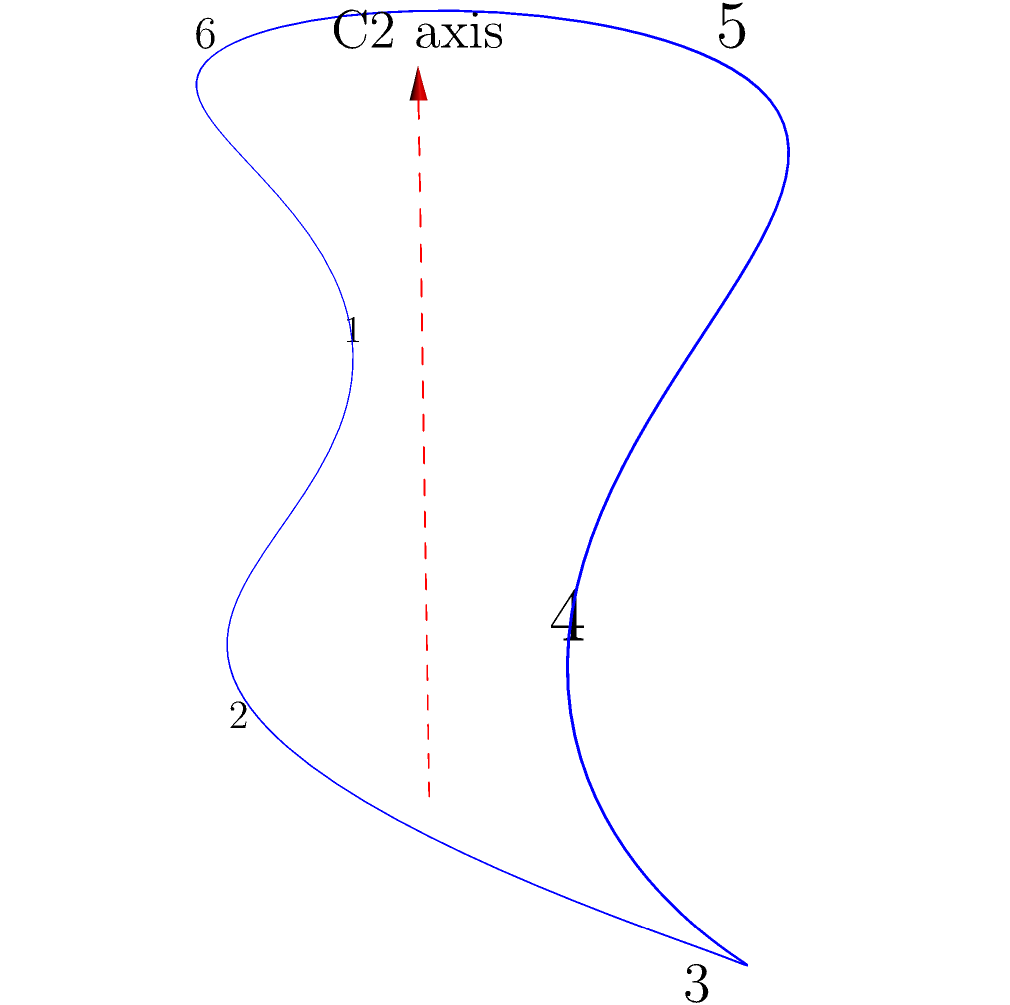Consider the cyclohexane chair conformation shown above, which is relevant to drug stereochemistry. Identify the order of the rotational symmetry operation about the C2 axis (shown in red) and determine how many different positions are generated by applying this operation repeatedly. How does this symmetry relate to the potential chirality of substituted cyclohexanes? To answer this question, let's follow these steps:

1. Understand the C2 axis:
   The C2 axis is a two-fold rotation axis that passes through the center of the cyclohexane ring.

2. Determine the order of rotation:
   - A C2 axis involves a 180° rotation (360°/2 = 180°).
   - This means the order of rotation is 2, as two rotations bring the molecule back to its original position.

3. Count the number of unique positions:
   - Starting position: original conformation
   - After one 180° rotation: new position
   - After two 180° rotations: back to the original position
   Thus, there are 2 unique positions generated by this symmetry operation.

4. Relate to chirality:
   - The C2 axis creates a plane of symmetry in the cyclohexane molecule.
   - This symmetry element means that unsubstituted cyclohexane is achiral.
   - However, if we substitute different groups on carbons not related by the C2 axis (e.g., carbons 1 and 4), we can create a chiral molecule.
   - Substitutions on carbons related by the C2 axis (e.g., carbons 2 and 5) will maintain the symmetry and result in an achiral molecule.

5. Pharmaceutical relevance:
   - Understanding these symmetry operations is crucial in drug design, as the chirality of a molecule can significantly affect its biological activity and interactions with target receptors.
   - This knowledge helps in predicting and controlling the stereochemistry of drug molecules, which is essential for their efficacy and safety.
Answer: Order: 2; Unique positions: 2; Chirality: C2 axis allows for chiral substitutions on non-symmetry-related carbons. 